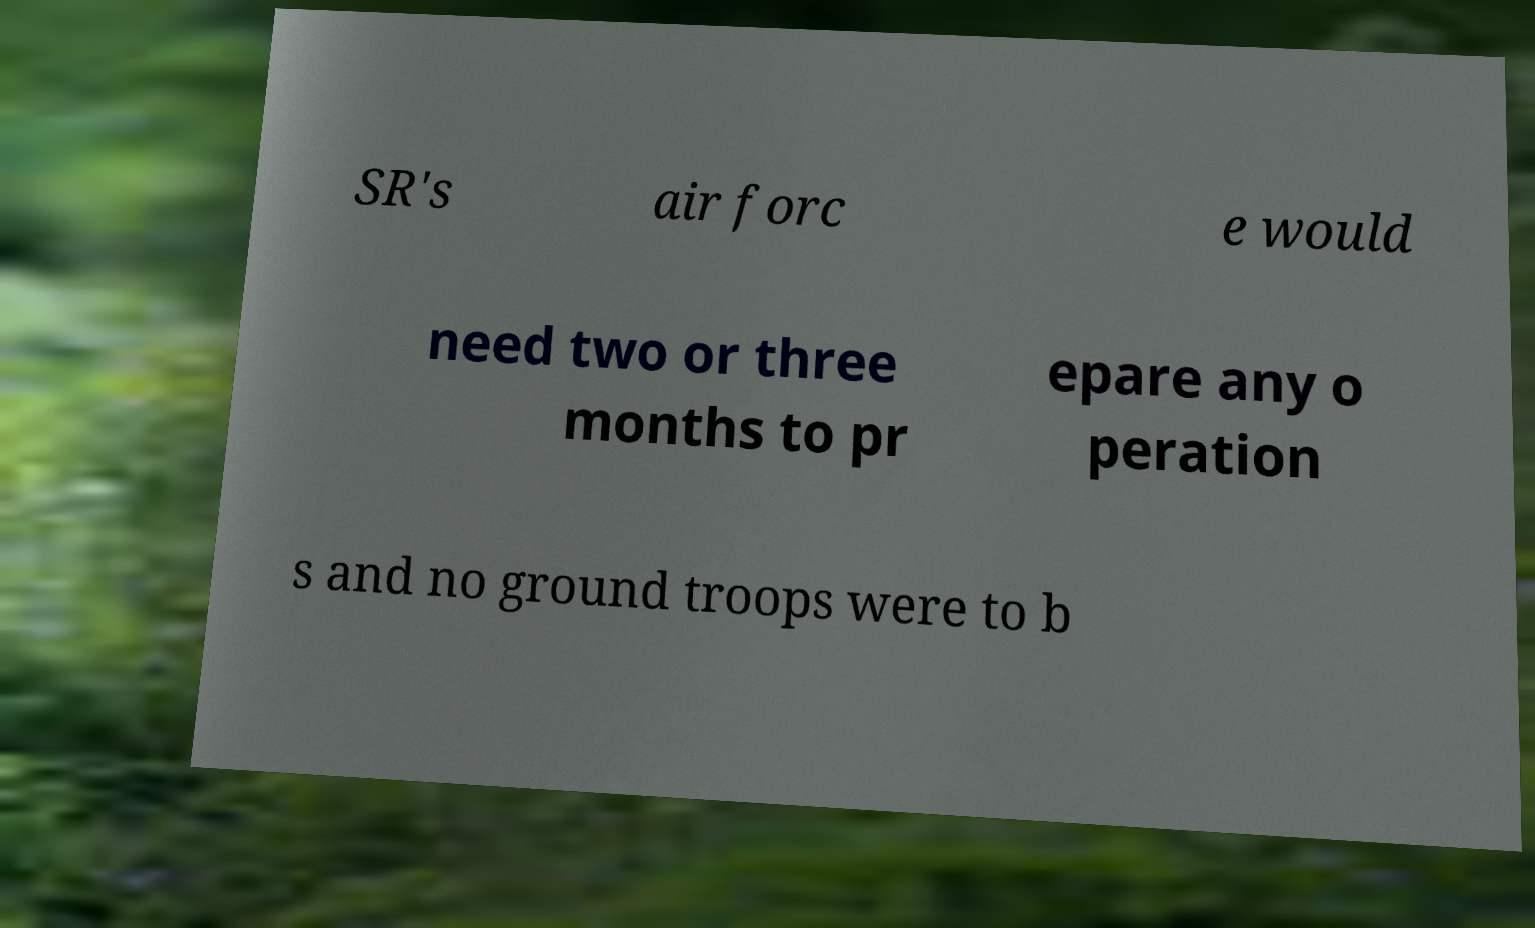There's text embedded in this image that I need extracted. Can you transcribe it verbatim? SR's air forc e would need two or three months to pr epare any o peration s and no ground troops were to b 